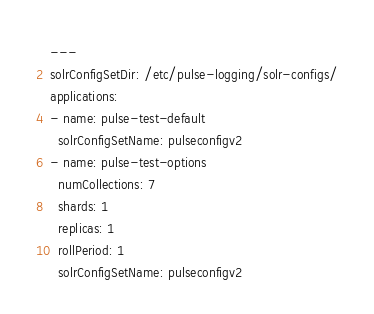Convert code to text. <code><loc_0><loc_0><loc_500><loc_500><_YAML_>---
solrConfigSetDir: /etc/pulse-logging/solr-configs/
applications:
- name: pulse-test-default
  solrConfigSetName: pulseconfigv2
- name: pulse-test-options
  numCollections: 7
  shards: 1
  replicas: 1
  rollPeriod: 1
  solrConfigSetName: pulseconfigv2
</code> 